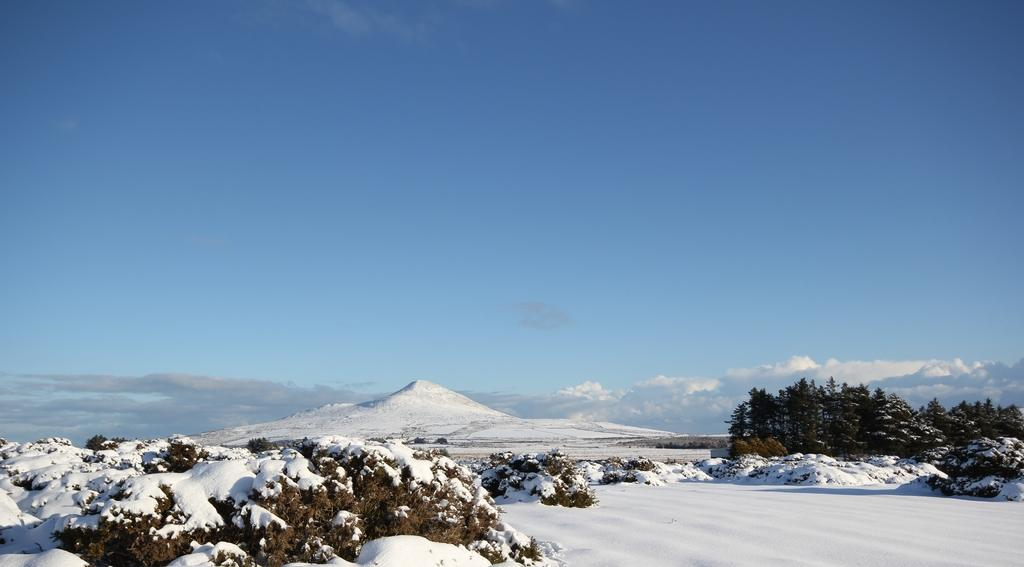What is the predominant weather condition in the image? There is snow in the image, indicating a cold and wintry condition. What type of natural vegetation can be seen in the image? There are trees in the image. What is visible in the sky in the image? Clouds are visible in the sky in the image. What size is the sponge used for cleaning the snow in the image? There is no sponge present in the image, as it is a natural snowfall and not a result of artificial snow-making. 